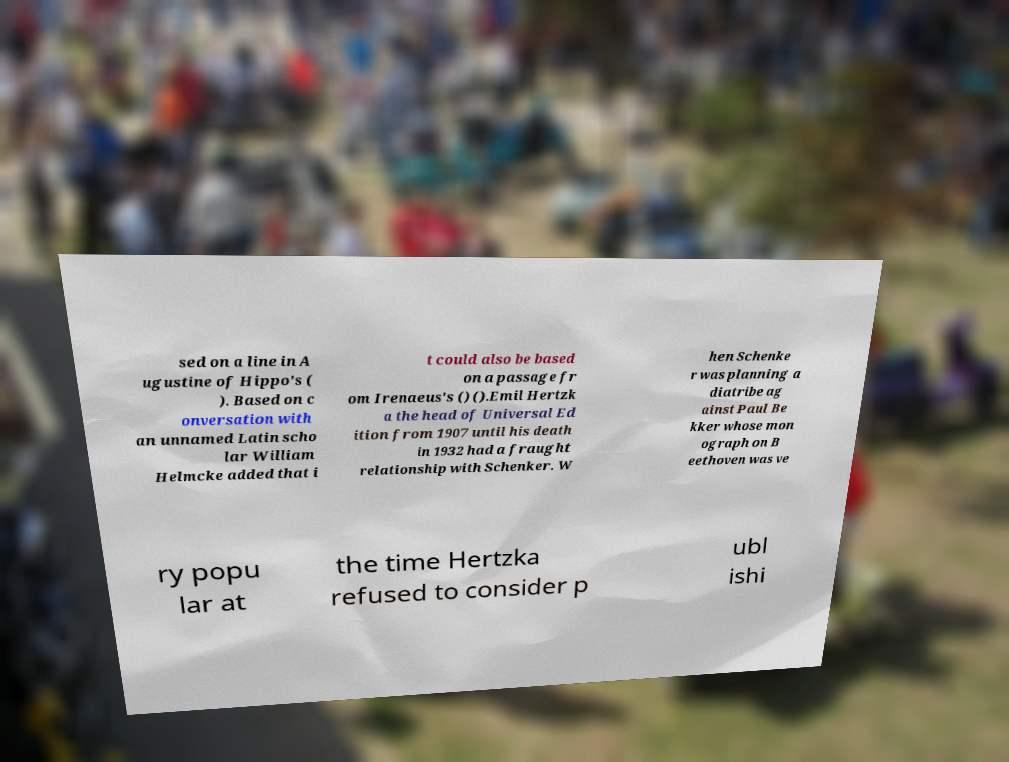There's text embedded in this image that I need extracted. Can you transcribe it verbatim? sed on a line in A ugustine of Hippo's ( ). Based on c onversation with an unnamed Latin scho lar William Helmcke added that i t could also be based on a passage fr om Irenaeus's () ().Emil Hertzk a the head of Universal Ed ition from 1907 until his death in 1932 had a fraught relationship with Schenker. W hen Schenke r was planning a diatribe ag ainst Paul Be kker whose mon ograph on B eethoven was ve ry popu lar at the time Hertzka refused to consider p ubl ishi 